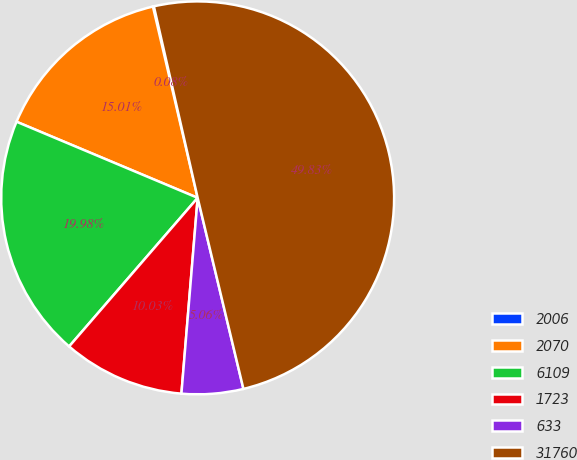Convert chart. <chart><loc_0><loc_0><loc_500><loc_500><pie_chart><fcel>2006<fcel>2070<fcel>6109<fcel>1723<fcel>633<fcel>31760<nl><fcel>0.08%<fcel>15.01%<fcel>19.98%<fcel>10.03%<fcel>5.06%<fcel>49.83%<nl></chart> 